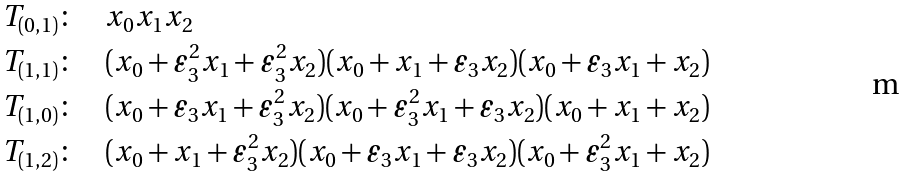<formula> <loc_0><loc_0><loc_500><loc_500>T _ { ( 0 , 1 ) } & \colon \quad x _ { 0 } x _ { 1 } x _ { 2 } \\ T _ { ( 1 , 1 ) } & \colon \quad ( x _ { 0 } + \varepsilon _ { 3 } ^ { 2 } x _ { 1 } + \varepsilon _ { 3 } ^ { 2 } x _ { 2 } ) ( x _ { 0 } + x _ { 1 } + \varepsilon _ { 3 } x _ { 2 } ) ( x _ { 0 } + \varepsilon _ { 3 } x _ { 1 } + x _ { 2 } ) \\ T _ { ( 1 , 0 ) } & \colon \quad ( x _ { 0 } + \varepsilon _ { 3 } x _ { 1 } + \varepsilon _ { 3 } ^ { 2 } x _ { 2 } ) ( x _ { 0 } + \varepsilon _ { 3 } ^ { 2 } x _ { 1 } + \varepsilon _ { 3 } x _ { 2 } ) ( x _ { 0 } + x _ { 1 } + x _ { 2 } ) \\ T _ { ( 1 , 2 ) } & \colon \quad ( x _ { 0 } + x _ { 1 } + \varepsilon _ { 3 } ^ { 2 } x _ { 2 } ) ( x _ { 0 } + \varepsilon _ { 3 } x _ { 1 } + \varepsilon _ { 3 } x _ { 2 } ) ( x _ { 0 } + \varepsilon _ { 3 } ^ { 2 } x _ { 1 } + x _ { 2 } )</formula> 